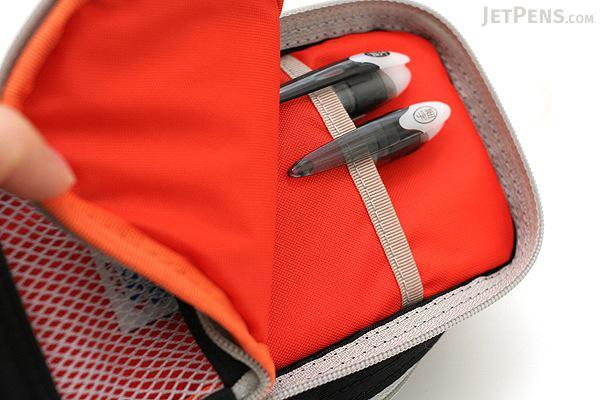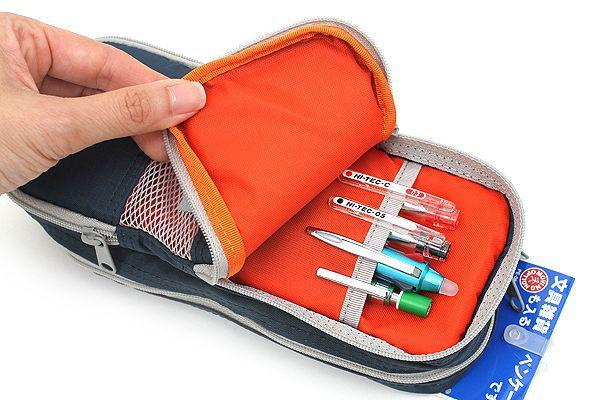The first image is the image on the left, the second image is the image on the right. For the images shown, is this caption "At least one of the images has a hand holding the pouch open." true? Answer yes or no. Yes. The first image is the image on the left, the second image is the image on the right. Given the left and right images, does the statement "A hand is opening the pencil case in at least one image." hold true? Answer yes or no. Yes. 